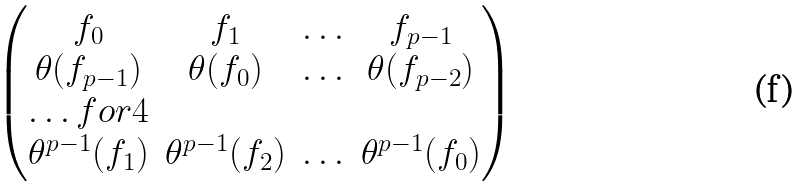Convert formula to latex. <formula><loc_0><loc_0><loc_500><loc_500>\begin{pmatrix} f _ { 0 } & f _ { 1 } & \hdots & f _ { p - 1 } \\ \theta ( f _ { p - 1 } ) & \theta ( f _ { 0 } ) & \hdots & \theta ( f _ { p - 2 } ) \\ \hdots f o r 4 \\ \theta ^ { p - 1 } ( f _ { 1 } ) & \theta ^ { p - 1 } ( f _ { 2 } ) & \hdots & \theta ^ { p - 1 } ( f _ { 0 } ) \end{pmatrix}</formula> 